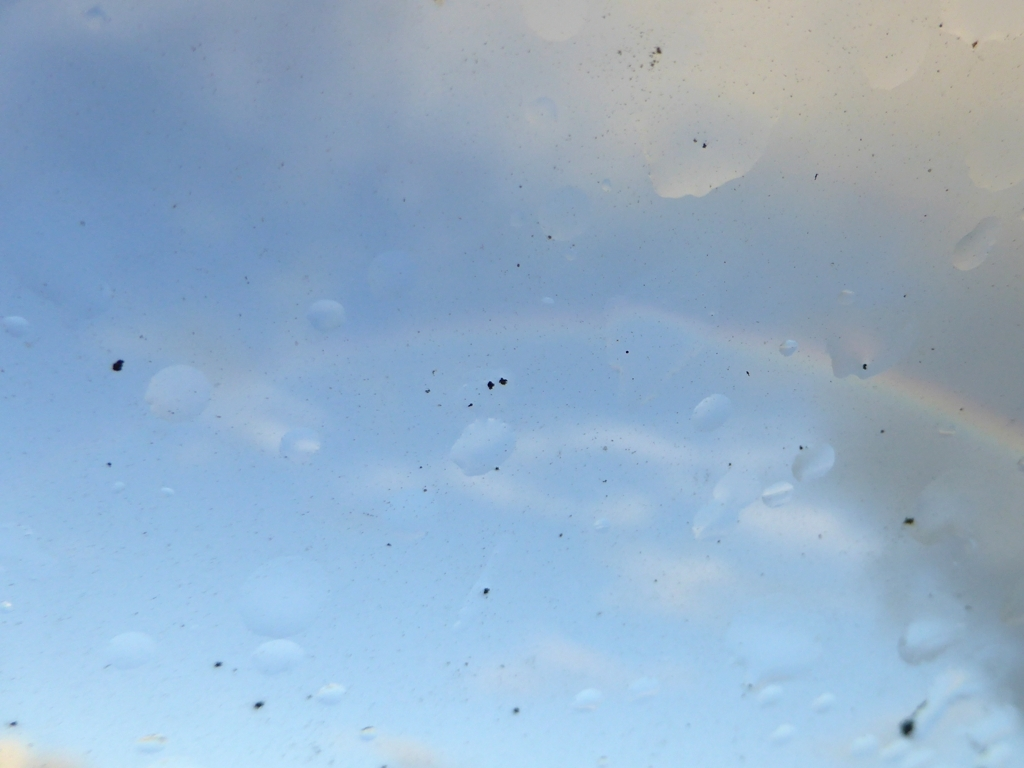Could this photo be improved with editing? If so, how? Yes, the photo could potentially be improved by adjusting the contrast and sharpness to make the rainbow more prominent. Additionally, cropping could help focus on the most visually interesting areas. Would this image serve any purpose in its current state? In its current state, this image could evoke a sense of serenity or be used to illustrate concepts like weather conditions or obstructed vision. 